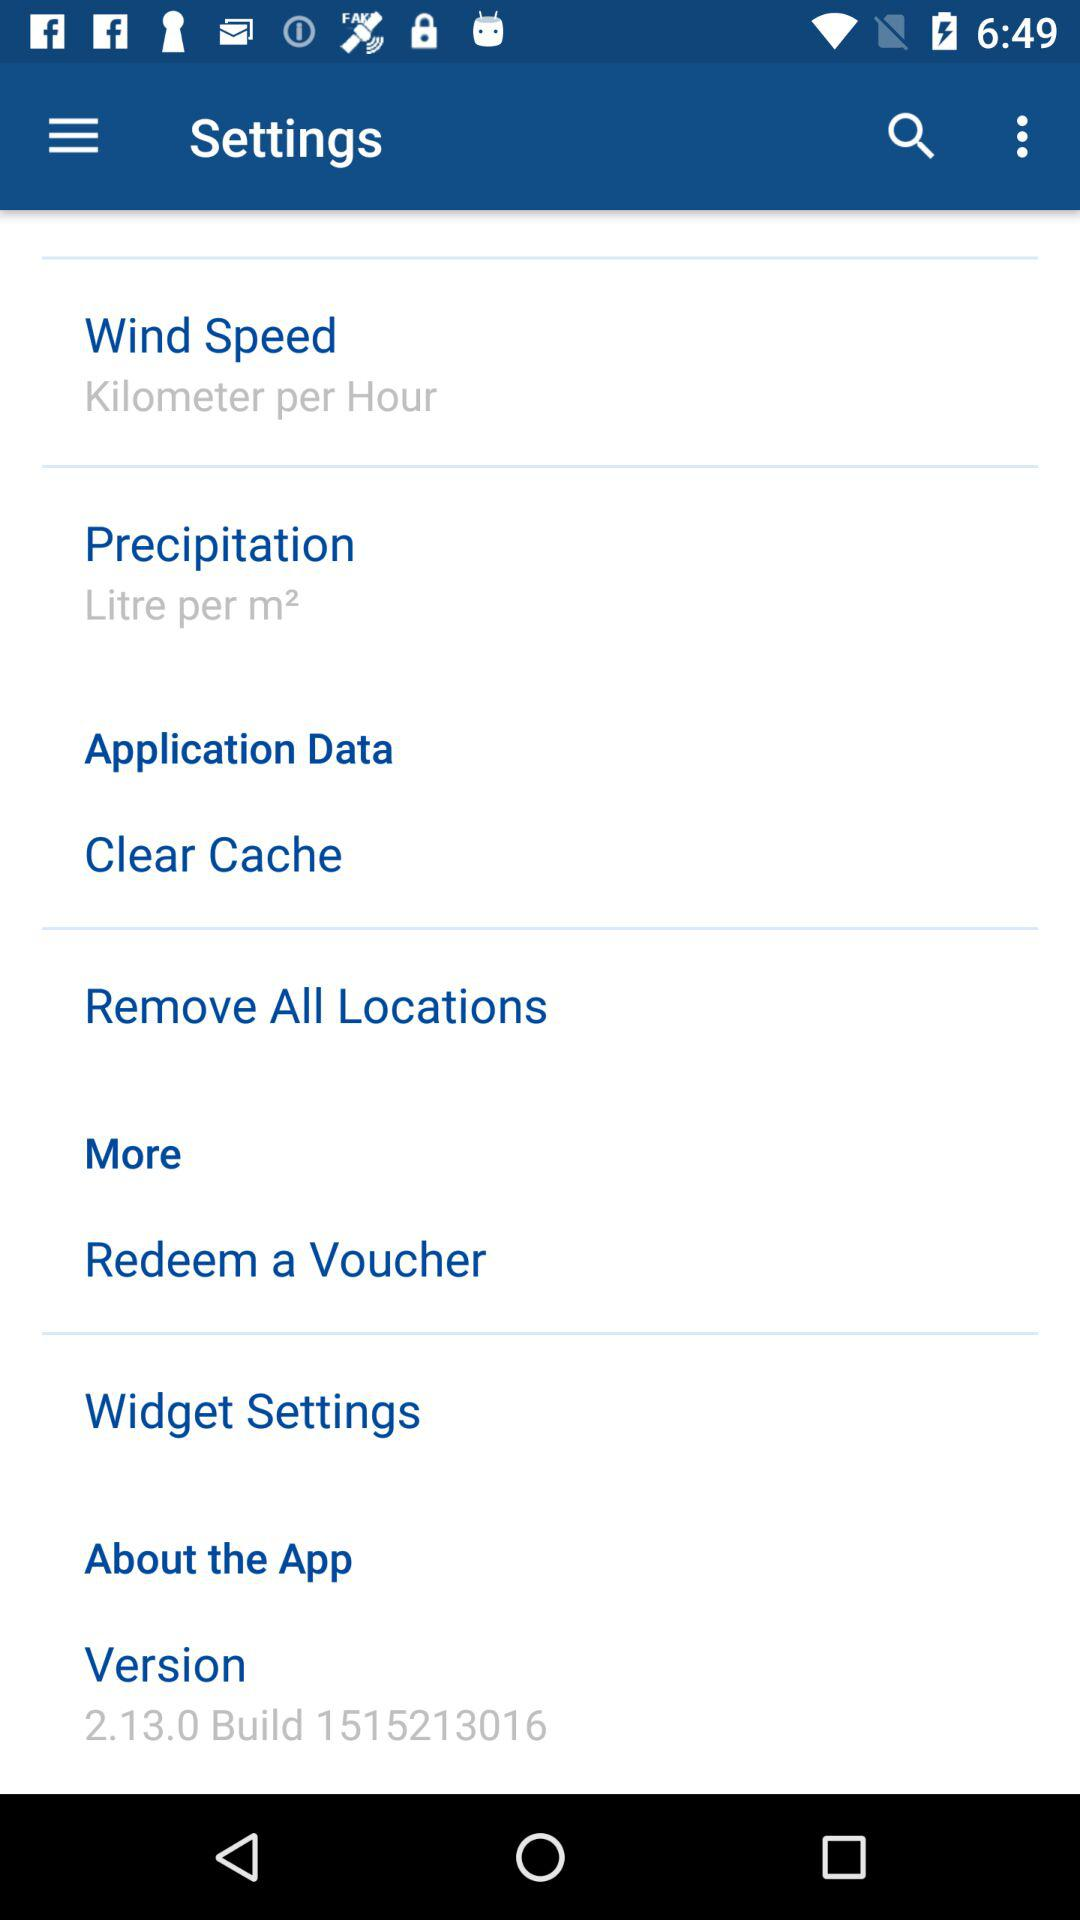What is the version of the app? The version of the app is 2.13.0 Build 1515213016. 